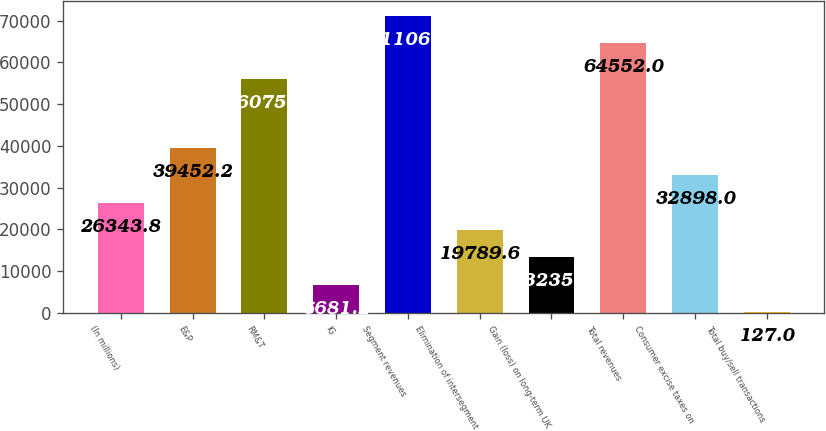Convert chart to OTSL. <chart><loc_0><loc_0><loc_500><loc_500><bar_chart><fcel>(In millions)<fcel>E&P<fcel>RM&T<fcel>IG<fcel>Segment revenues<fcel>Elimination of intersegment<fcel>Gain (loss) on long-term UK<fcel>Total revenues<fcel>Consumer excise taxes on<fcel>Total buy/sell transactions<nl><fcel>26343.8<fcel>39452.2<fcel>56075<fcel>6681.2<fcel>71106.2<fcel>19789.6<fcel>13235.4<fcel>64552<fcel>32898<fcel>127<nl></chart> 